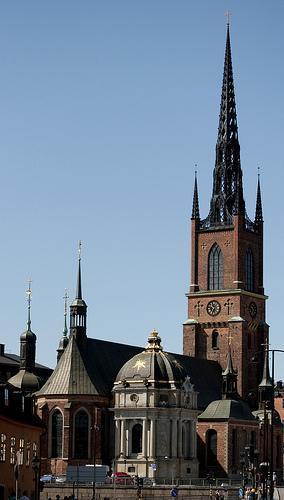How many tall buildings are there?
Give a very brief answer. 1. 